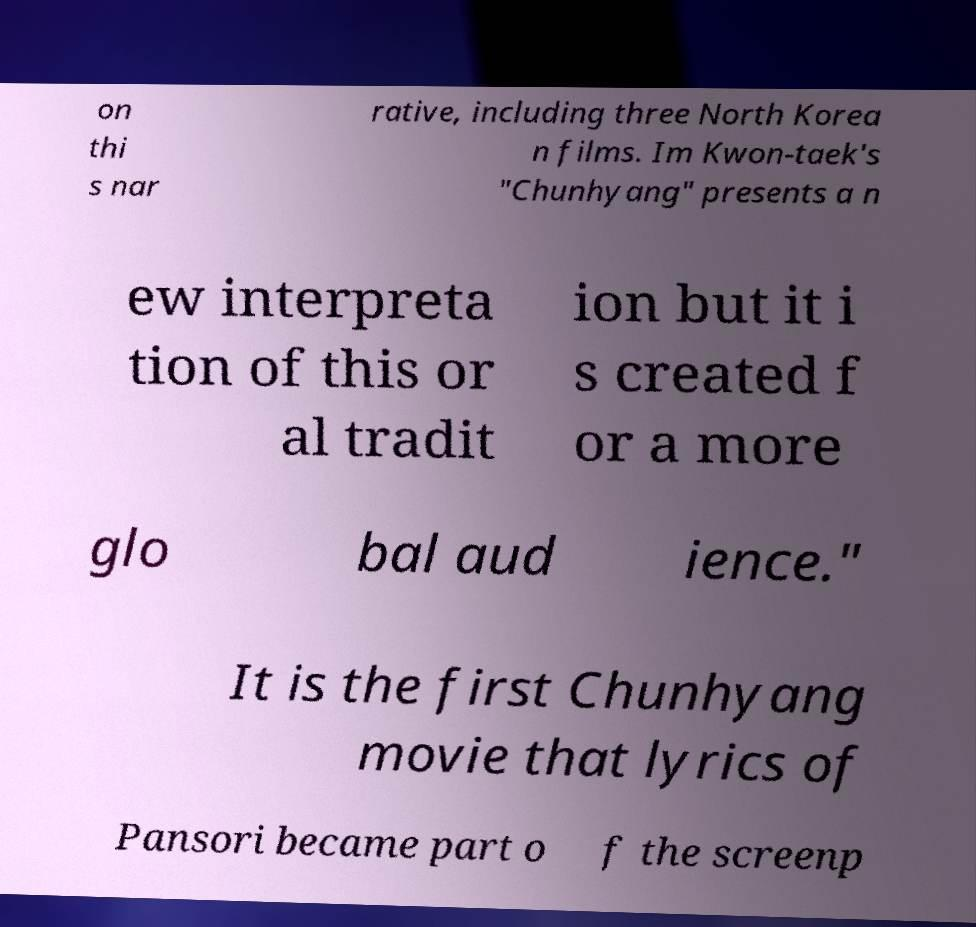Can you read and provide the text displayed in the image?This photo seems to have some interesting text. Can you extract and type it out for me? on thi s nar rative, including three North Korea n films. Im Kwon-taek's "Chunhyang" presents a n ew interpreta tion of this or al tradit ion but it i s created f or a more glo bal aud ience." It is the first Chunhyang movie that lyrics of Pansori became part o f the screenp 